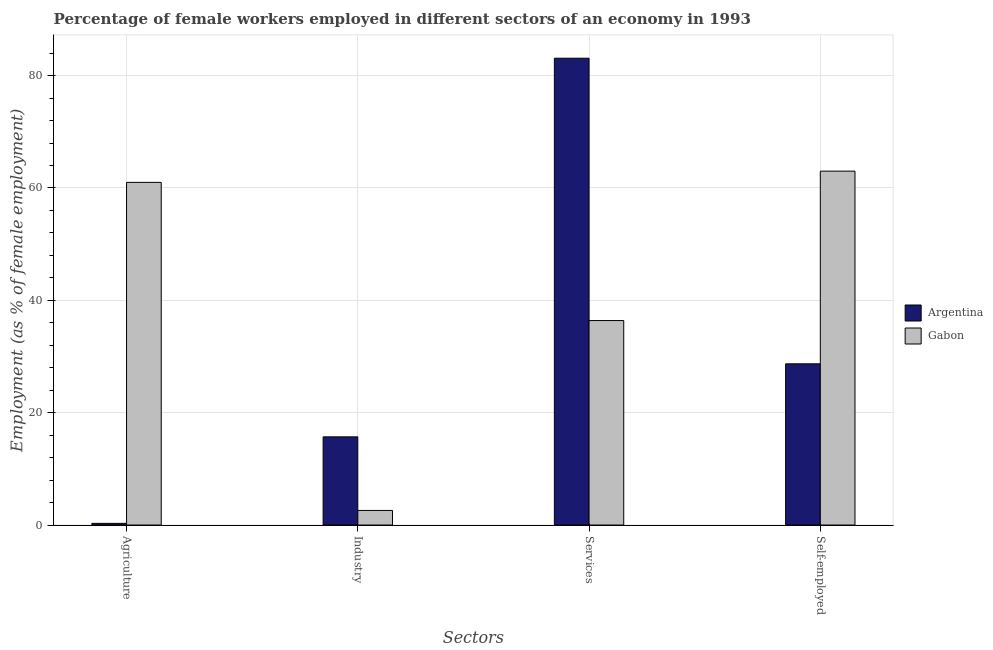How many different coloured bars are there?
Provide a succinct answer. 2. Are the number of bars on each tick of the X-axis equal?
Offer a terse response. Yes. What is the label of the 4th group of bars from the left?
Ensure brevity in your answer.  Self-employed. What is the percentage of self employed female workers in Argentina?
Offer a terse response. 28.7. Across all countries, what is the maximum percentage of female workers in industry?
Make the answer very short. 15.7. Across all countries, what is the minimum percentage of female workers in industry?
Your response must be concise. 2.6. What is the total percentage of self employed female workers in the graph?
Keep it short and to the point. 91.7. What is the difference between the percentage of female workers in services in Gabon and that in Argentina?
Your answer should be compact. -46.7. What is the difference between the percentage of female workers in services in Argentina and the percentage of female workers in industry in Gabon?
Provide a succinct answer. 80.5. What is the average percentage of self employed female workers per country?
Provide a succinct answer. 45.85. What is the difference between the percentage of female workers in industry and percentage of female workers in agriculture in Argentina?
Your answer should be compact. 15.4. What is the ratio of the percentage of self employed female workers in Gabon to that in Argentina?
Offer a terse response. 2.2. Is the difference between the percentage of self employed female workers in Argentina and Gabon greater than the difference between the percentage of female workers in agriculture in Argentina and Gabon?
Provide a short and direct response. Yes. What is the difference between the highest and the second highest percentage of self employed female workers?
Make the answer very short. 34.3. What is the difference between the highest and the lowest percentage of female workers in industry?
Give a very brief answer. 13.1. Is it the case that in every country, the sum of the percentage of female workers in services and percentage of self employed female workers is greater than the sum of percentage of female workers in industry and percentage of female workers in agriculture?
Your response must be concise. Yes. Is it the case that in every country, the sum of the percentage of female workers in agriculture and percentage of female workers in industry is greater than the percentage of female workers in services?
Give a very brief answer. No. How many bars are there?
Your response must be concise. 8. Are all the bars in the graph horizontal?
Provide a succinct answer. No. Are the values on the major ticks of Y-axis written in scientific E-notation?
Make the answer very short. No. Does the graph contain any zero values?
Your answer should be compact. No. Does the graph contain grids?
Your answer should be very brief. Yes. Where does the legend appear in the graph?
Give a very brief answer. Center right. How are the legend labels stacked?
Your answer should be very brief. Vertical. What is the title of the graph?
Offer a very short reply. Percentage of female workers employed in different sectors of an economy in 1993. What is the label or title of the X-axis?
Offer a very short reply. Sectors. What is the label or title of the Y-axis?
Give a very brief answer. Employment (as % of female employment). What is the Employment (as % of female employment) of Argentina in Agriculture?
Provide a succinct answer. 0.3. What is the Employment (as % of female employment) of Gabon in Agriculture?
Offer a very short reply. 61. What is the Employment (as % of female employment) of Argentina in Industry?
Make the answer very short. 15.7. What is the Employment (as % of female employment) in Gabon in Industry?
Offer a terse response. 2.6. What is the Employment (as % of female employment) of Argentina in Services?
Your response must be concise. 83.1. What is the Employment (as % of female employment) of Gabon in Services?
Ensure brevity in your answer.  36.4. What is the Employment (as % of female employment) of Argentina in Self-employed?
Keep it short and to the point. 28.7. Across all Sectors, what is the maximum Employment (as % of female employment) of Argentina?
Offer a terse response. 83.1. Across all Sectors, what is the maximum Employment (as % of female employment) in Gabon?
Make the answer very short. 63. Across all Sectors, what is the minimum Employment (as % of female employment) in Argentina?
Your response must be concise. 0.3. Across all Sectors, what is the minimum Employment (as % of female employment) of Gabon?
Provide a succinct answer. 2.6. What is the total Employment (as % of female employment) in Argentina in the graph?
Offer a terse response. 127.8. What is the total Employment (as % of female employment) of Gabon in the graph?
Ensure brevity in your answer.  163. What is the difference between the Employment (as % of female employment) in Argentina in Agriculture and that in Industry?
Provide a short and direct response. -15.4. What is the difference between the Employment (as % of female employment) in Gabon in Agriculture and that in Industry?
Make the answer very short. 58.4. What is the difference between the Employment (as % of female employment) of Argentina in Agriculture and that in Services?
Your response must be concise. -82.8. What is the difference between the Employment (as % of female employment) in Gabon in Agriculture and that in Services?
Provide a succinct answer. 24.6. What is the difference between the Employment (as % of female employment) of Argentina in Agriculture and that in Self-employed?
Give a very brief answer. -28.4. What is the difference between the Employment (as % of female employment) in Argentina in Industry and that in Services?
Provide a succinct answer. -67.4. What is the difference between the Employment (as % of female employment) of Gabon in Industry and that in Services?
Provide a short and direct response. -33.8. What is the difference between the Employment (as % of female employment) in Gabon in Industry and that in Self-employed?
Give a very brief answer. -60.4. What is the difference between the Employment (as % of female employment) of Argentina in Services and that in Self-employed?
Ensure brevity in your answer.  54.4. What is the difference between the Employment (as % of female employment) of Gabon in Services and that in Self-employed?
Your answer should be very brief. -26.6. What is the difference between the Employment (as % of female employment) of Argentina in Agriculture and the Employment (as % of female employment) of Gabon in Industry?
Provide a short and direct response. -2.3. What is the difference between the Employment (as % of female employment) in Argentina in Agriculture and the Employment (as % of female employment) in Gabon in Services?
Offer a very short reply. -36.1. What is the difference between the Employment (as % of female employment) in Argentina in Agriculture and the Employment (as % of female employment) in Gabon in Self-employed?
Keep it short and to the point. -62.7. What is the difference between the Employment (as % of female employment) of Argentina in Industry and the Employment (as % of female employment) of Gabon in Services?
Ensure brevity in your answer.  -20.7. What is the difference between the Employment (as % of female employment) of Argentina in Industry and the Employment (as % of female employment) of Gabon in Self-employed?
Ensure brevity in your answer.  -47.3. What is the difference between the Employment (as % of female employment) in Argentina in Services and the Employment (as % of female employment) in Gabon in Self-employed?
Your answer should be very brief. 20.1. What is the average Employment (as % of female employment) in Argentina per Sectors?
Ensure brevity in your answer.  31.95. What is the average Employment (as % of female employment) of Gabon per Sectors?
Your answer should be compact. 40.75. What is the difference between the Employment (as % of female employment) of Argentina and Employment (as % of female employment) of Gabon in Agriculture?
Offer a very short reply. -60.7. What is the difference between the Employment (as % of female employment) in Argentina and Employment (as % of female employment) in Gabon in Industry?
Provide a succinct answer. 13.1. What is the difference between the Employment (as % of female employment) of Argentina and Employment (as % of female employment) of Gabon in Services?
Your response must be concise. 46.7. What is the difference between the Employment (as % of female employment) in Argentina and Employment (as % of female employment) in Gabon in Self-employed?
Your answer should be compact. -34.3. What is the ratio of the Employment (as % of female employment) in Argentina in Agriculture to that in Industry?
Your answer should be compact. 0.02. What is the ratio of the Employment (as % of female employment) in Gabon in Agriculture to that in Industry?
Provide a short and direct response. 23.46. What is the ratio of the Employment (as % of female employment) of Argentina in Agriculture to that in Services?
Your response must be concise. 0. What is the ratio of the Employment (as % of female employment) of Gabon in Agriculture to that in Services?
Your answer should be compact. 1.68. What is the ratio of the Employment (as % of female employment) in Argentina in Agriculture to that in Self-employed?
Ensure brevity in your answer.  0.01. What is the ratio of the Employment (as % of female employment) of Gabon in Agriculture to that in Self-employed?
Give a very brief answer. 0.97. What is the ratio of the Employment (as % of female employment) of Argentina in Industry to that in Services?
Provide a succinct answer. 0.19. What is the ratio of the Employment (as % of female employment) in Gabon in Industry to that in Services?
Provide a short and direct response. 0.07. What is the ratio of the Employment (as % of female employment) of Argentina in Industry to that in Self-employed?
Provide a succinct answer. 0.55. What is the ratio of the Employment (as % of female employment) in Gabon in Industry to that in Self-employed?
Offer a very short reply. 0.04. What is the ratio of the Employment (as % of female employment) in Argentina in Services to that in Self-employed?
Offer a terse response. 2.9. What is the ratio of the Employment (as % of female employment) in Gabon in Services to that in Self-employed?
Offer a terse response. 0.58. What is the difference between the highest and the second highest Employment (as % of female employment) in Argentina?
Your answer should be very brief. 54.4. What is the difference between the highest and the lowest Employment (as % of female employment) in Argentina?
Provide a short and direct response. 82.8. What is the difference between the highest and the lowest Employment (as % of female employment) in Gabon?
Offer a terse response. 60.4. 